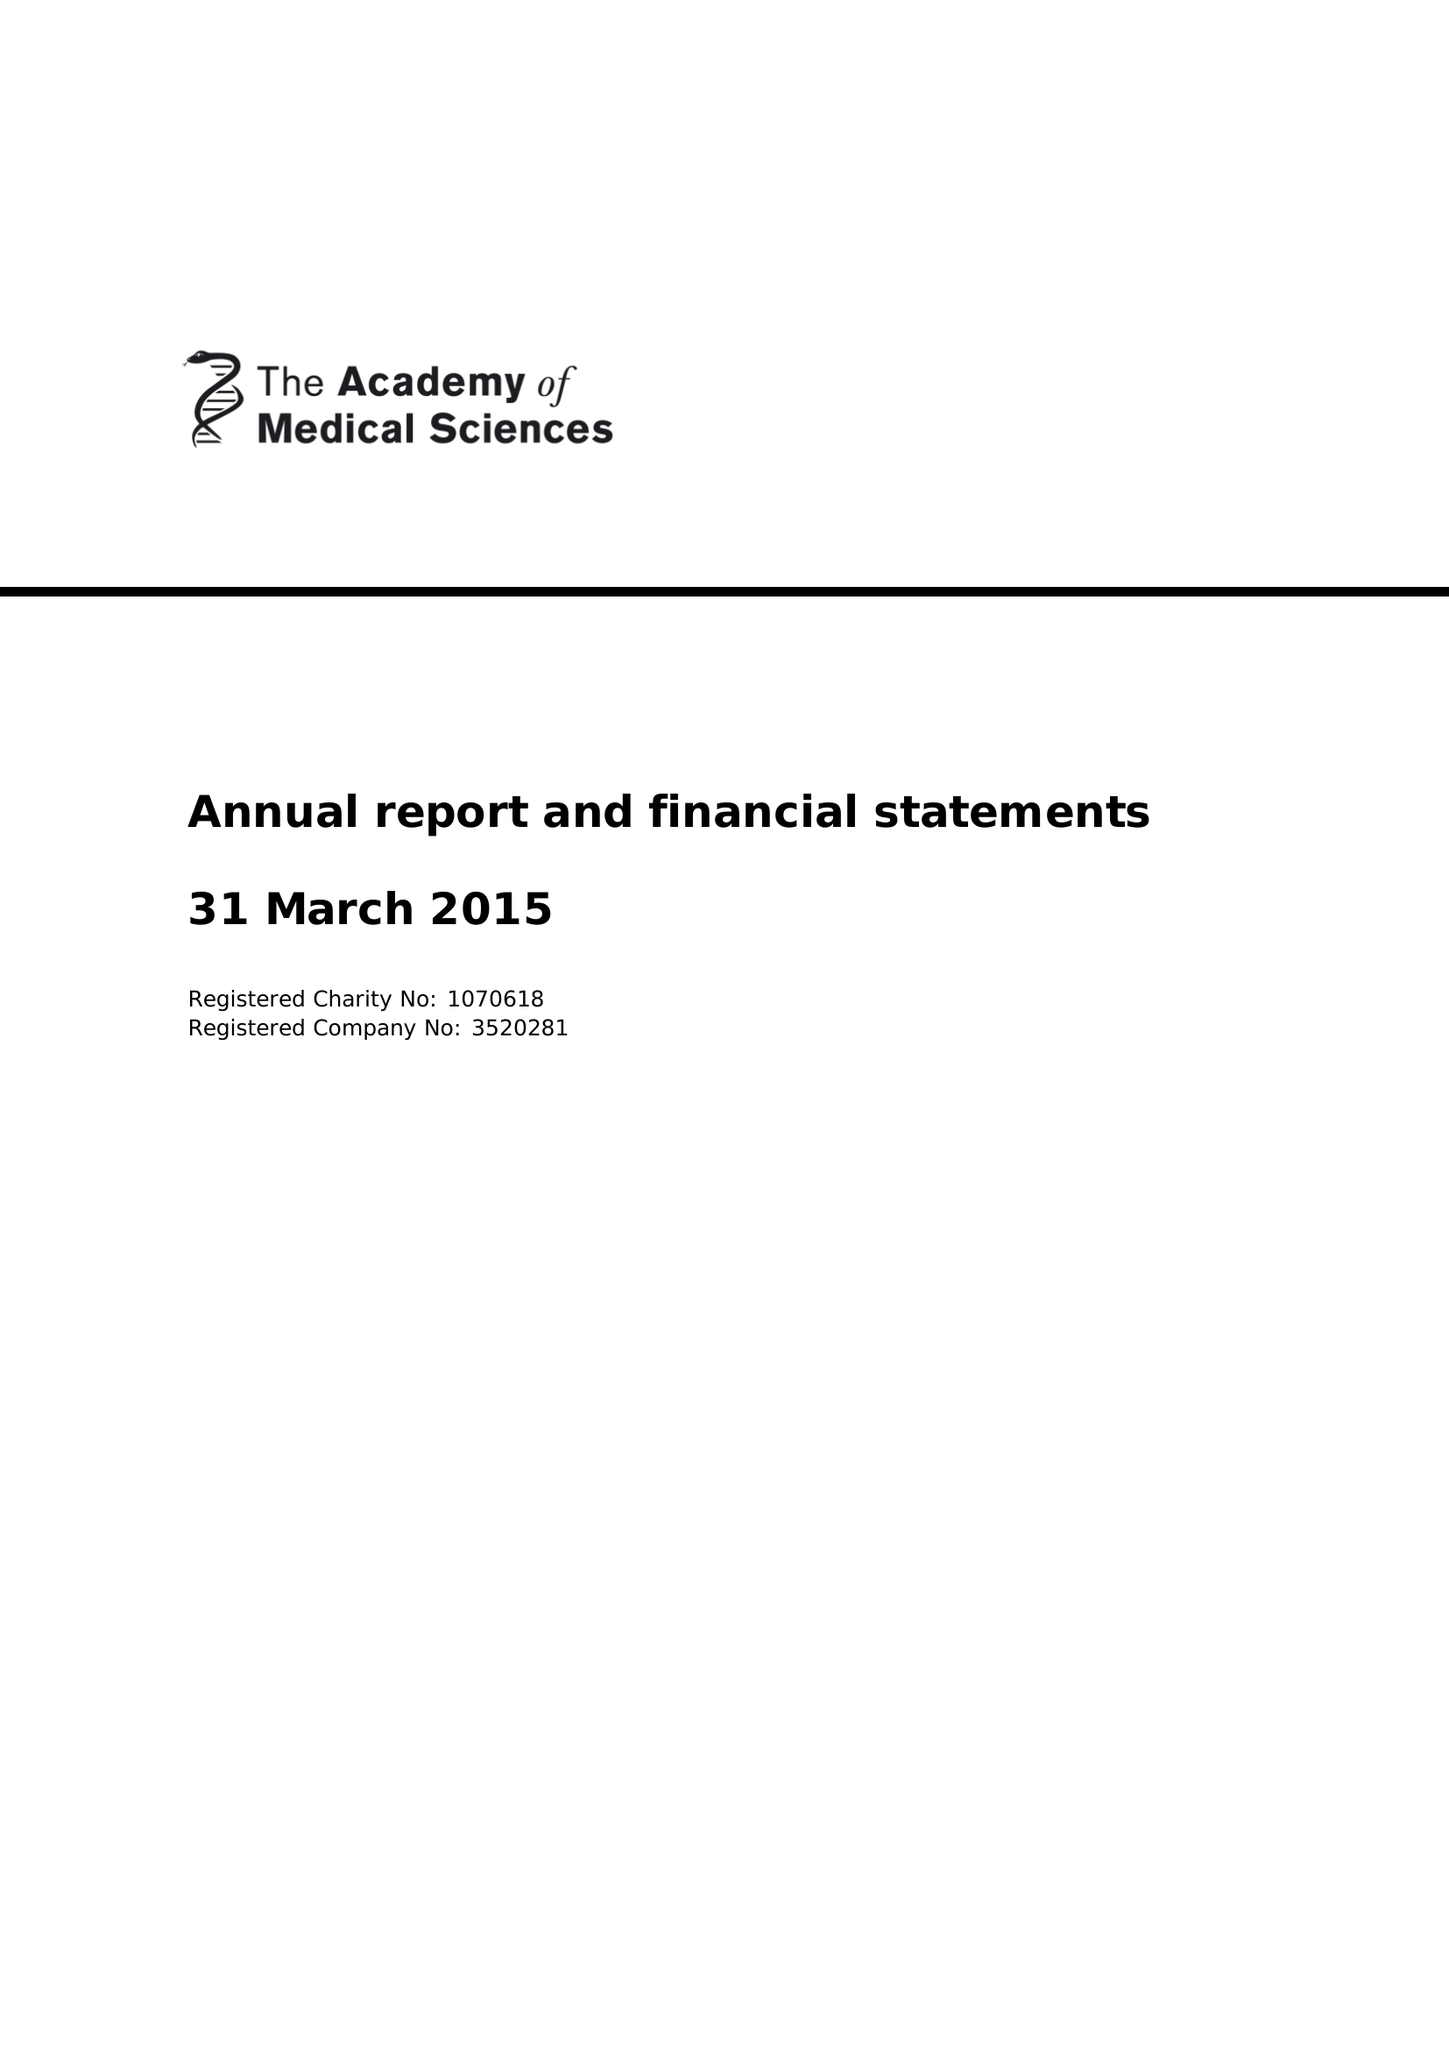What is the value for the address__postcode?
Answer the question using a single word or phrase. W1B 1QH 